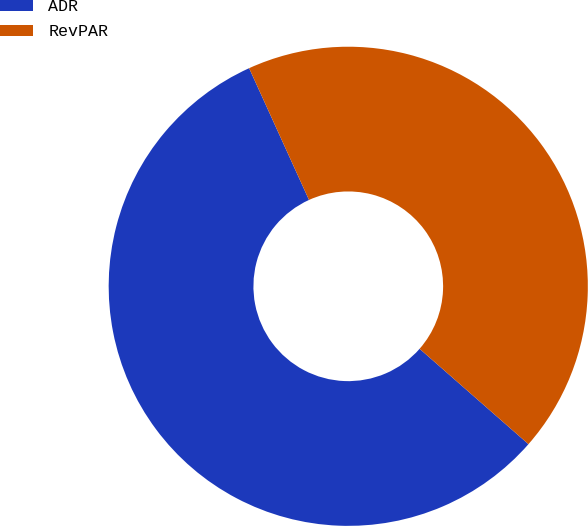Convert chart to OTSL. <chart><loc_0><loc_0><loc_500><loc_500><pie_chart><fcel>ADR<fcel>RevPAR<nl><fcel>56.76%<fcel>43.24%<nl></chart> 